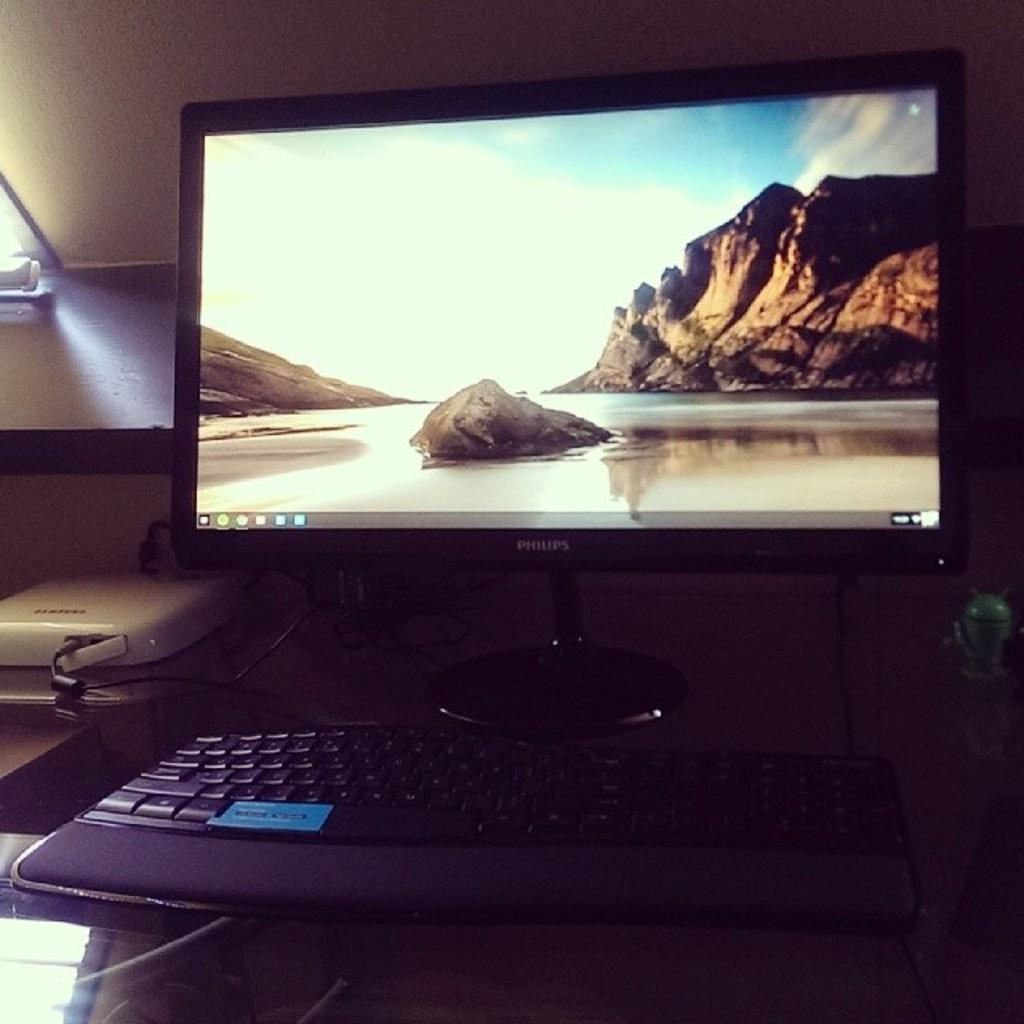<image>
Create a compact narrative representing the image presented. nA image of a shore and a cliff is on a Phillip's computer monitor. 